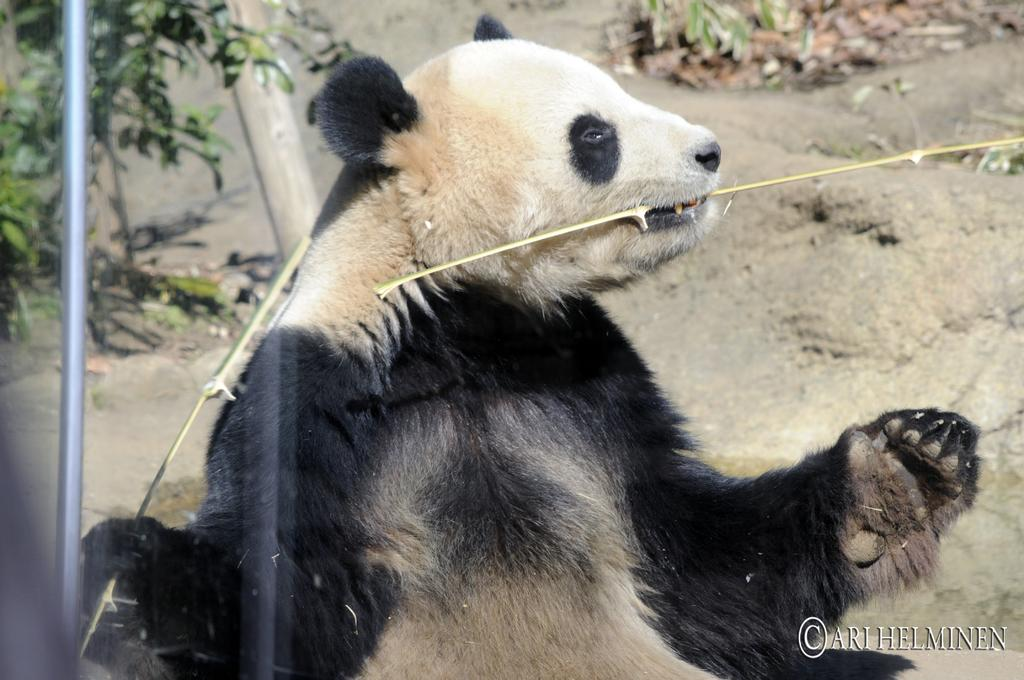What animal is the main subject of the image? There is a panda in the image. What colors can be seen on the panda? The panda is black and white in color. What is the panda holding in the image? The panda is holding sticks. What can be seen in the background of the image? There are plants in the background of the image. Can you describe any additional features of the image? There is a watermark in the image. What is the texture of the panda's fur in the image? The texture of the panda's fur cannot be determined from the image alone, as it is a 2D representation. 